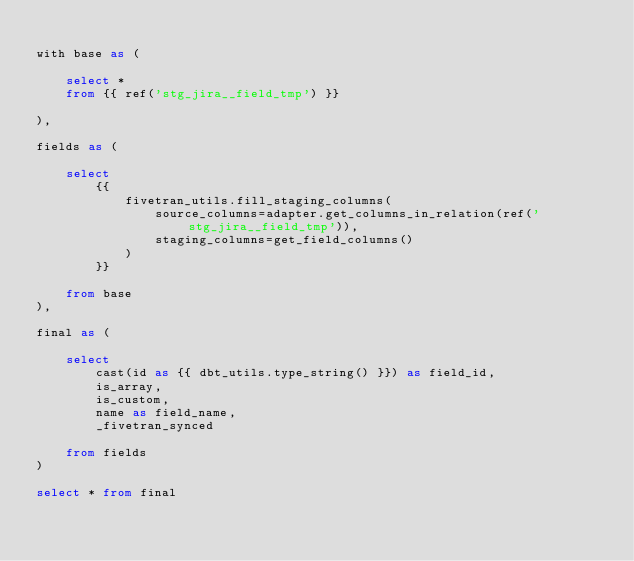Convert code to text. <code><loc_0><loc_0><loc_500><loc_500><_SQL_>
with base as (

    select * 
    from {{ ref('stg_jira__field_tmp') }}

),

fields as (

    select
        {{
            fivetran_utils.fill_staging_columns(
                source_columns=adapter.get_columns_in_relation(ref('stg_jira__field_tmp')),
                staging_columns=get_field_columns()
            )
        }}
        
    from base
),

final as (
    
    select 
        cast(id as {{ dbt_utils.type_string() }}) as field_id,
        is_array,
        is_custom,
        name as field_name,
        _fivetran_synced 
        
    from fields
)

select * from final
</code> 